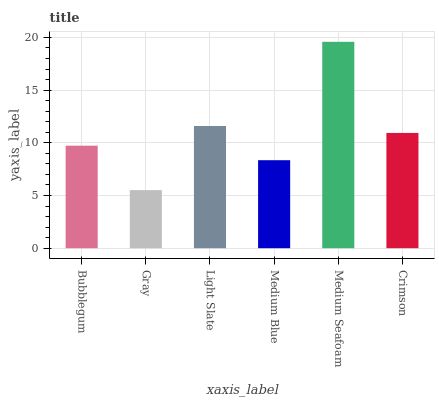Is Gray the minimum?
Answer yes or no. Yes. Is Medium Seafoam the maximum?
Answer yes or no. Yes. Is Light Slate the minimum?
Answer yes or no. No. Is Light Slate the maximum?
Answer yes or no. No. Is Light Slate greater than Gray?
Answer yes or no. Yes. Is Gray less than Light Slate?
Answer yes or no. Yes. Is Gray greater than Light Slate?
Answer yes or no. No. Is Light Slate less than Gray?
Answer yes or no. No. Is Crimson the high median?
Answer yes or no. Yes. Is Bubblegum the low median?
Answer yes or no. Yes. Is Bubblegum the high median?
Answer yes or no. No. Is Medium Blue the low median?
Answer yes or no. No. 